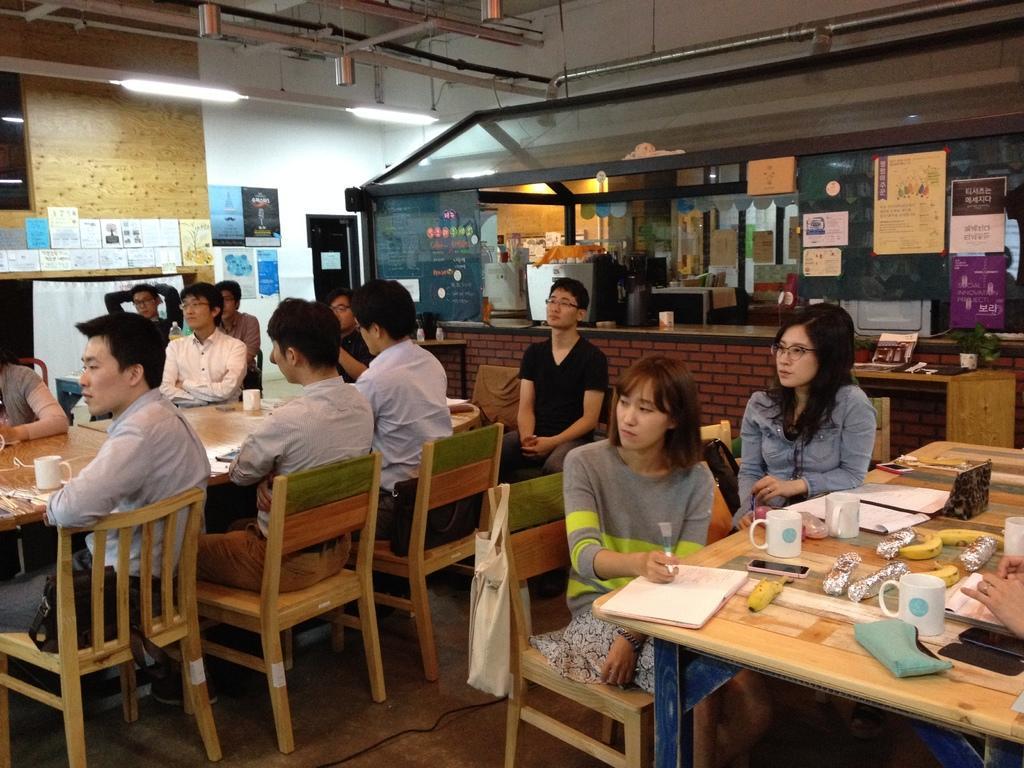Could you give a brief overview of what you see in this image? This picture describes about group of people, they are all seated on the chair, in front of them we can find couple of cups, fruits, papers, mobiles, books on the table, in the background we can see wall posters, oven and couple of lights. 